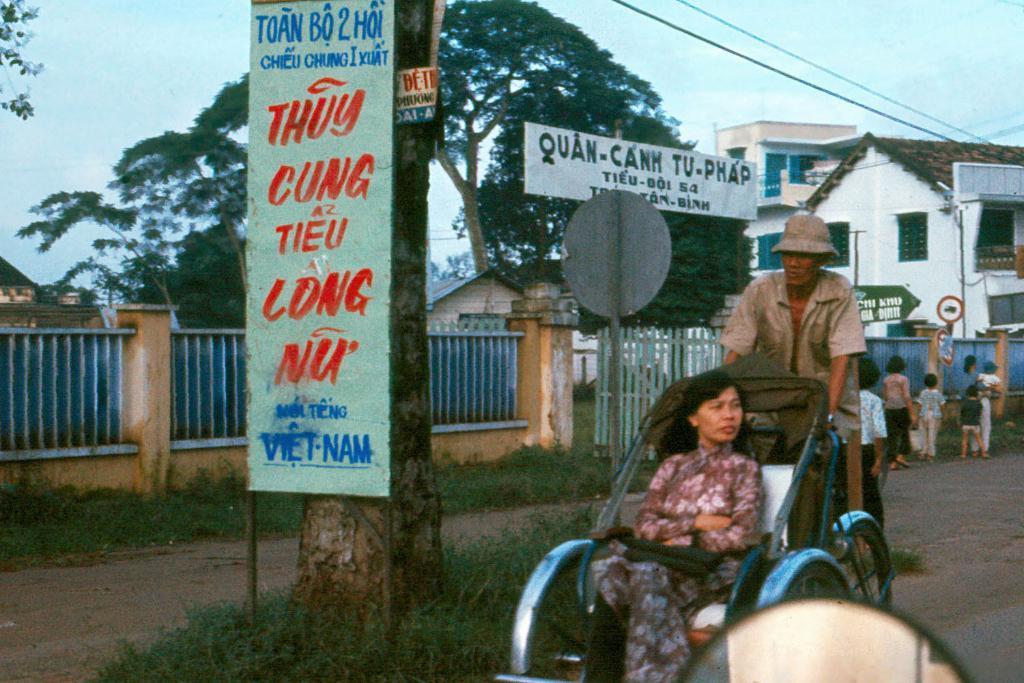How would you summarize this image in a sentence or two? In the image there is a man riding rickshaw with a woman in it, in the back there are buildings and a fence on the right side with few people walking over the road and above its sky. 